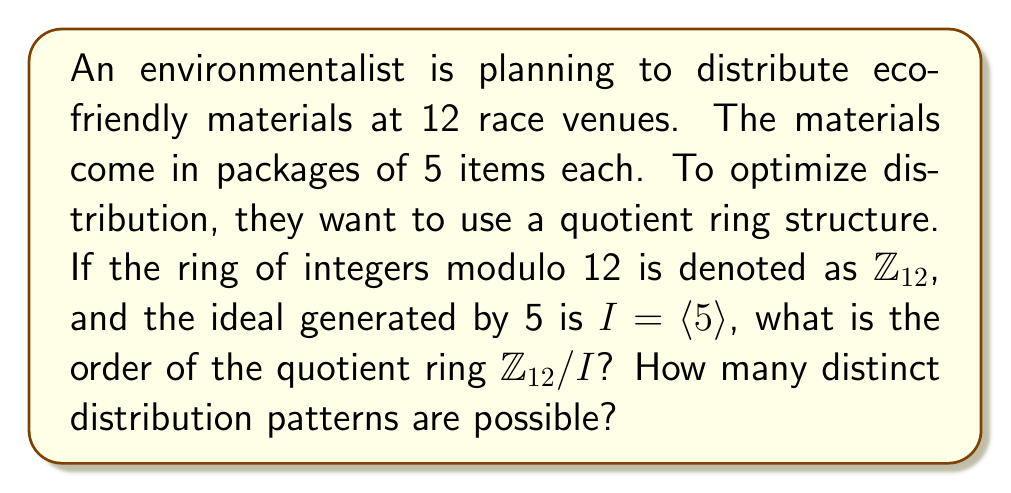Provide a solution to this math problem. To solve this problem, we need to follow these steps:

1) First, we need to understand what the ideal $I = \langle 5 \rangle$ represents in $\mathbb{Z}_{12}$:
   $I = \{0, 5, 10, 3, 8, 1, 6, 11, 4, 9, 2, 7\}$
   This is because in $\mathbb{Z}_{12}$, multiplying 5 by any element gives these results.

2) The quotient ring $\mathbb{Z}_{12}/I$ consists of cosets of $I$ in $\mathbb{Z}_{12}$. 

3) To find the order of $\mathbb{Z}_{12}/I$, we need to determine how many distinct cosets there are.

4) The number of distinct cosets is equal to the index of $I$ in $\mathbb{Z}_{12}$, which is given by:
   $[\mathbb{Z}_{12} : I] = |\mathbb{Z}_{12}| / |I|$

5) We know that $|\mathbb{Z}_{12}| = 12$, and from step 1, we can see that $|I| = 12$ as well.

6) Therefore, $[\mathbb{Z}_{12} : I] = 12 / 12 = 1$

7) This means there is only one coset, which is $I$ itself.

8) The order of the quotient ring $\mathbb{Z}_{12}/I$ is thus 1.

9) As for the number of distinct distribution patterns, since there is only one element in the quotient ring, there is only one possible distribution pattern.

This structure ensures that regardless of which venue the environmentalist starts at, the distribution will always follow the same pattern, optimizing the process for consistency across all venues.
Answer: The order of the quotient ring $\mathbb{Z}_{12}/I$ is 1, and there is only 1 distinct distribution pattern possible. 